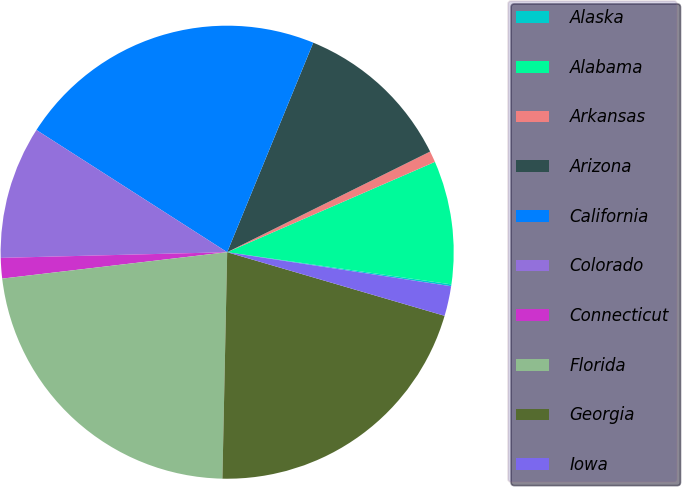Convert chart to OTSL. <chart><loc_0><loc_0><loc_500><loc_500><pie_chart><fcel>Alaska<fcel>Alabama<fcel>Arkansas<fcel>Arizona<fcel>California<fcel>Colorado<fcel>Connecticut<fcel>Florida<fcel>Georgia<fcel>Iowa<nl><fcel>0.13%<fcel>8.8%<fcel>0.8%<fcel>11.47%<fcel>22.14%<fcel>9.47%<fcel>1.46%<fcel>22.81%<fcel>20.81%<fcel>2.13%<nl></chart> 